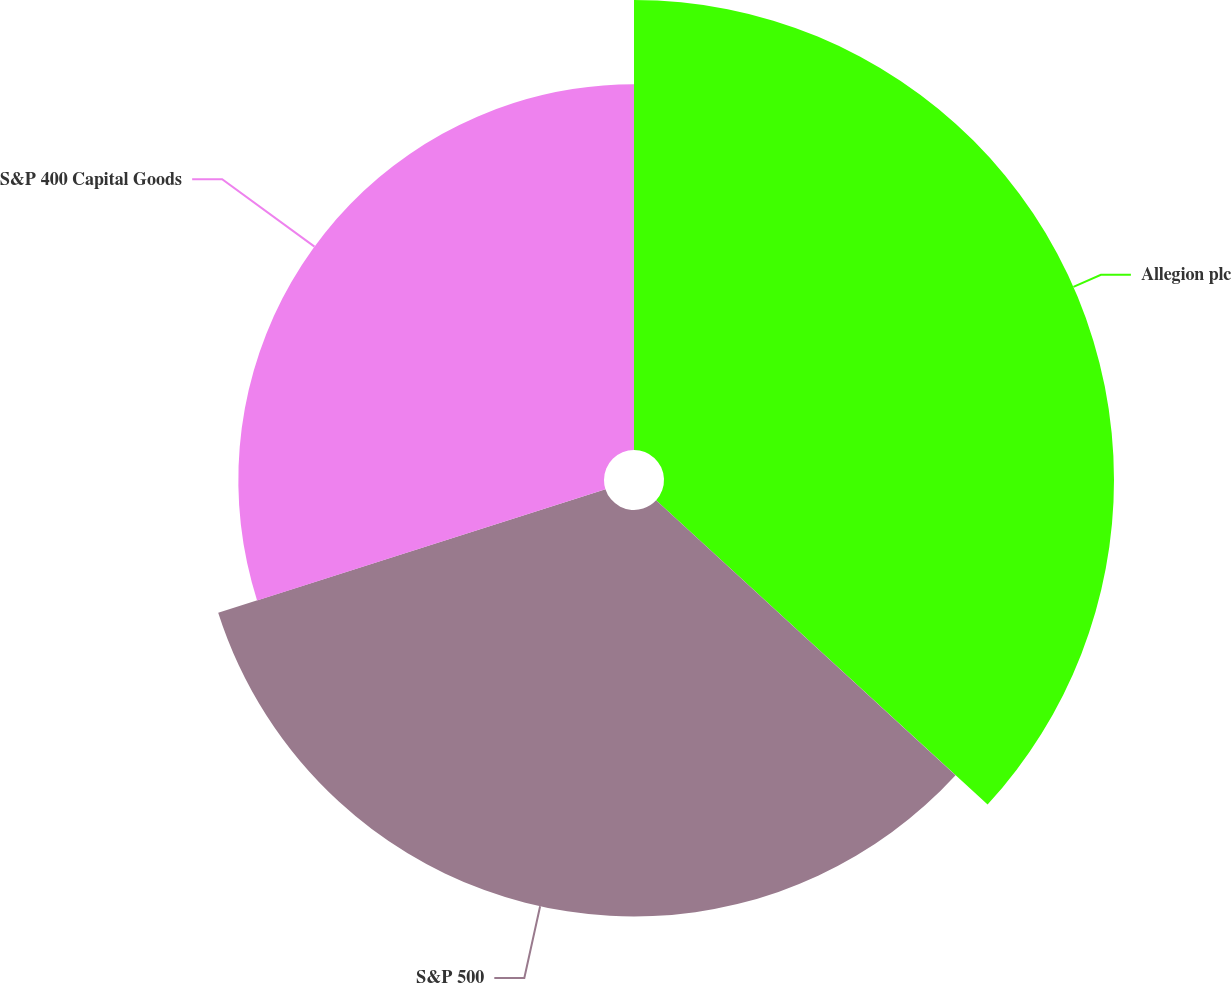Convert chart. <chart><loc_0><loc_0><loc_500><loc_500><pie_chart><fcel>Allegion plc<fcel>S&P 500<fcel>S&P 400 Capital Goods<nl><fcel>36.82%<fcel>33.26%<fcel>29.92%<nl></chart> 